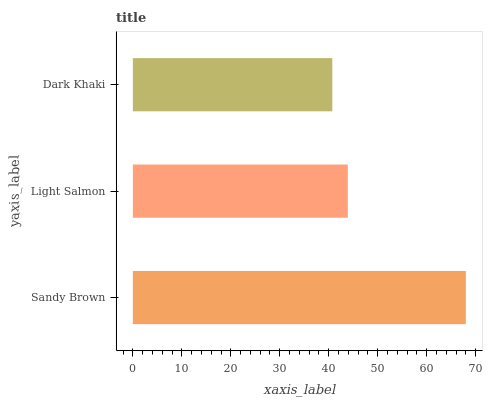Is Dark Khaki the minimum?
Answer yes or no. Yes. Is Sandy Brown the maximum?
Answer yes or no. Yes. Is Light Salmon the minimum?
Answer yes or no. No. Is Light Salmon the maximum?
Answer yes or no. No. Is Sandy Brown greater than Light Salmon?
Answer yes or no. Yes. Is Light Salmon less than Sandy Brown?
Answer yes or no. Yes. Is Light Salmon greater than Sandy Brown?
Answer yes or no. No. Is Sandy Brown less than Light Salmon?
Answer yes or no. No. Is Light Salmon the high median?
Answer yes or no. Yes. Is Light Salmon the low median?
Answer yes or no. Yes. Is Sandy Brown the high median?
Answer yes or no. No. Is Sandy Brown the low median?
Answer yes or no. No. 